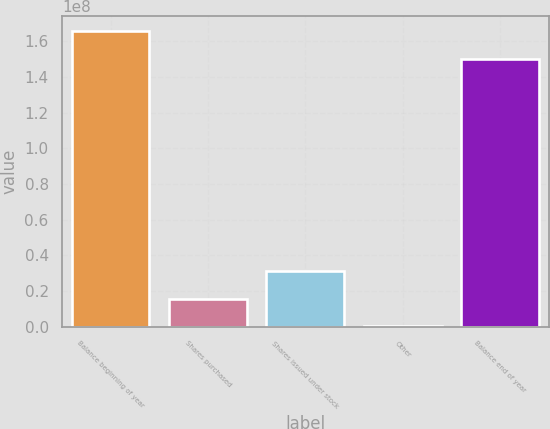Convert chart to OTSL. <chart><loc_0><loc_0><loc_500><loc_500><bar_chart><fcel>Balance beginning of year<fcel>Shares purchased<fcel>Shares issued under stock<fcel>Other<fcel>Balance end of year<nl><fcel>1.65574e+08<fcel>1.57002e+07<fcel>3.11424e+07<fcel>257883<fcel>1.50131e+08<nl></chart> 